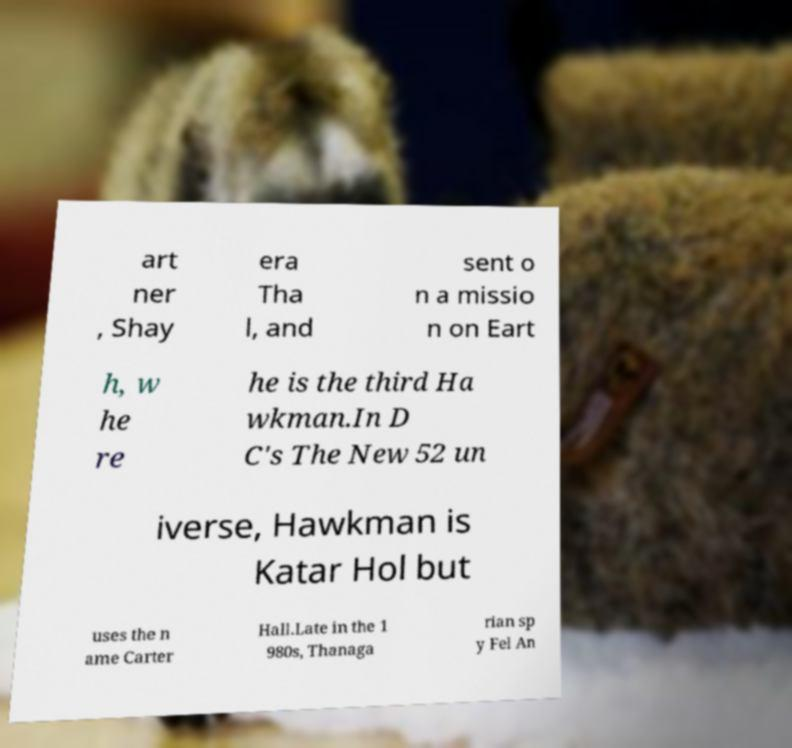Please read and relay the text visible in this image. What does it say? art ner , Shay era Tha l, and sent o n a missio n on Eart h, w he re he is the third Ha wkman.In D C's The New 52 un iverse, Hawkman is Katar Hol but uses the n ame Carter Hall.Late in the 1 980s, Thanaga rian sp y Fel An 